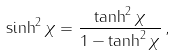Convert formula to latex. <formula><loc_0><loc_0><loc_500><loc_500>\sinh ^ { 2 } \chi = \frac { \tanh ^ { 2 } \chi } { 1 - \tanh ^ { 2 } \chi } \, ,</formula> 